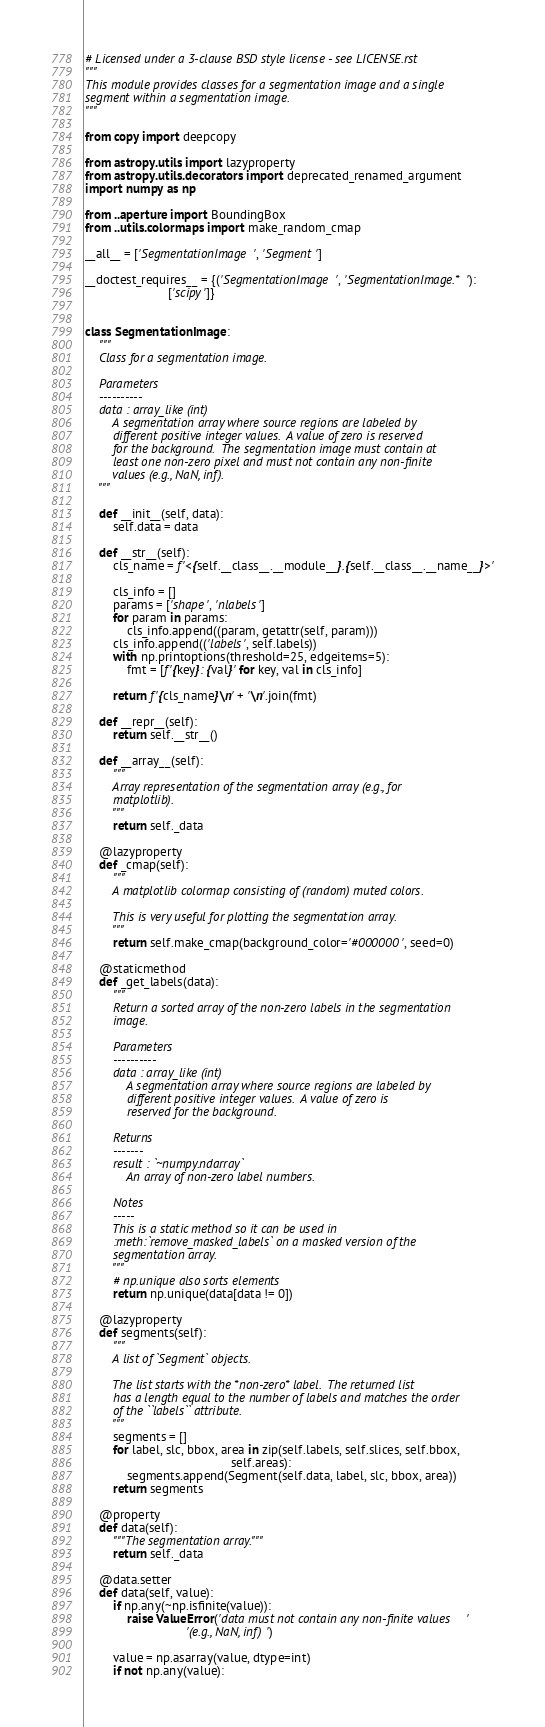<code> <loc_0><loc_0><loc_500><loc_500><_Python_># Licensed under a 3-clause BSD style license - see LICENSE.rst
"""
This module provides classes for a segmentation image and a single
segment within a segmentation image.
"""

from copy import deepcopy

from astropy.utils import lazyproperty
from astropy.utils.decorators import deprecated_renamed_argument
import numpy as np

from ..aperture import BoundingBox
from ..utils.colormaps import make_random_cmap

__all__ = ['SegmentationImage', 'Segment']

__doctest_requires__ = {('SegmentationImage', 'SegmentationImage.*'):
                        ['scipy']}


class SegmentationImage:
    """
    Class for a segmentation image.

    Parameters
    ----------
    data : array_like (int)
        A segmentation array where source regions are labeled by
        different positive integer values.  A value of zero is reserved
        for the background.  The segmentation image must contain at
        least one non-zero pixel and must not contain any non-finite
        values (e.g., NaN, inf).
    """

    def __init__(self, data):
        self.data = data

    def __str__(self):
        cls_name = f'<{self.__class__.__module__}.{self.__class__.__name__}>'

        cls_info = []
        params = ['shape', 'nlabels']
        for param in params:
            cls_info.append((param, getattr(self, param)))
        cls_info.append(('labels', self.labels))
        with np.printoptions(threshold=25, edgeitems=5):
            fmt = [f'{key}: {val}' for key, val in cls_info]

        return f'{cls_name}\n' + '\n'.join(fmt)

    def __repr__(self):
        return self.__str__()

    def __array__(self):
        """
        Array representation of the segmentation array (e.g., for
        matplotlib).
        """
        return self._data

    @lazyproperty
    def _cmap(self):
        """
        A matplotlib colormap consisting of (random) muted colors.

        This is very useful for plotting the segmentation array.
        """
        return self.make_cmap(background_color='#000000', seed=0)

    @staticmethod
    def _get_labels(data):
        """
        Return a sorted array of the non-zero labels in the segmentation
        image.

        Parameters
        ----------
        data : array_like (int)
            A segmentation array where source regions are labeled by
            different positive integer values.  A value of zero is
            reserved for the background.

        Returns
        -------
        result : `~numpy.ndarray`
            An array of non-zero label numbers.

        Notes
        -----
        This is a static method so it can be used in
        :meth:`remove_masked_labels` on a masked version of the
        segmentation array.
        """
        # np.unique also sorts elements
        return np.unique(data[data != 0])

    @lazyproperty
    def segments(self):
        """
        A list of `Segment` objects.

        The list starts with the *non-zero* label.  The returned list
        has a length equal to the number of labels and matches the order
        of the ``labels`` attribute.
        """
        segments = []
        for label, slc, bbox, area in zip(self.labels, self.slices, self.bbox,
                                          self.areas):
            segments.append(Segment(self.data, label, slc, bbox, area))
        return segments

    @property
    def data(self):
        """The segmentation array."""
        return self._data

    @data.setter
    def data(self, value):
        if np.any(~np.isfinite(value)):
            raise ValueError('data must not contain any non-finite values '
                             '(e.g., NaN, inf)')

        value = np.asarray(value, dtype=int)
        if not np.any(value):</code> 